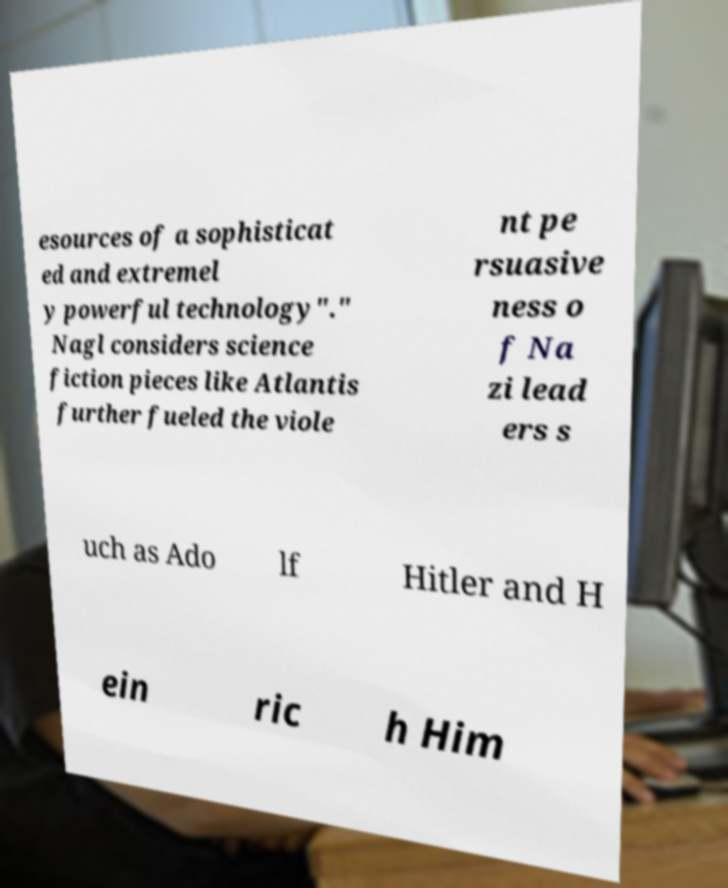Could you assist in decoding the text presented in this image and type it out clearly? esources of a sophisticat ed and extremel y powerful technology"." Nagl considers science fiction pieces like Atlantis further fueled the viole nt pe rsuasive ness o f Na zi lead ers s uch as Ado lf Hitler and H ein ric h Him 